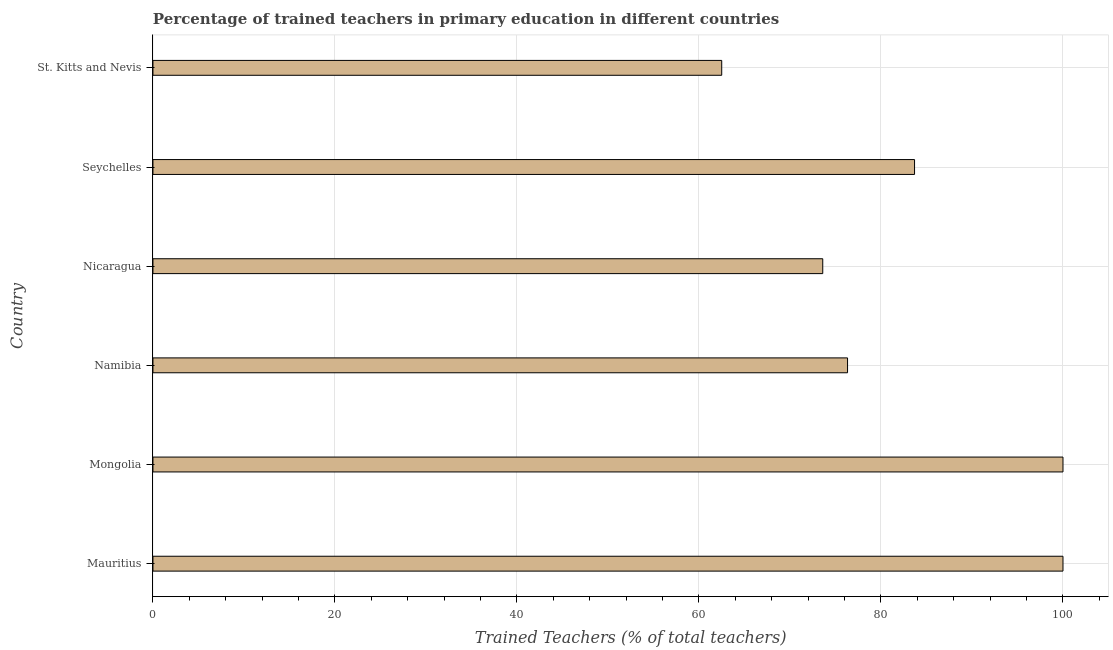Does the graph contain grids?
Your answer should be very brief. Yes. What is the title of the graph?
Make the answer very short. Percentage of trained teachers in primary education in different countries. What is the label or title of the X-axis?
Keep it short and to the point. Trained Teachers (% of total teachers). What is the label or title of the Y-axis?
Ensure brevity in your answer.  Country. What is the percentage of trained teachers in St. Kitts and Nevis?
Provide a short and direct response. 62.5. Across all countries, what is the maximum percentage of trained teachers?
Provide a succinct answer. 100. Across all countries, what is the minimum percentage of trained teachers?
Make the answer very short. 62.5. In which country was the percentage of trained teachers maximum?
Offer a very short reply. Mauritius. In which country was the percentage of trained teachers minimum?
Keep it short and to the point. St. Kitts and Nevis. What is the sum of the percentage of trained teachers?
Provide a short and direct response. 496.12. What is the difference between the percentage of trained teachers in Mongolia and Nicaragua?
Keep it short and to the point. 26.4. What is the average percentage of trained teachers per country?
Make the answer very short. 82.69. What is the median percentage of trained teachers?
Give a very brief answer. 80.01. What is the ratio of the percentage of trained teachers in Mongolia to that in Seychelles?
Give a very brief answer. 1.2. What is the difference between the highest and the second highest percentage of trained teachers?
Your answer should be very brief. 0. Is the sum of the percentage of trained teachers in Seychelles and St. Kitts and Nevis greater than the maximum percentage of trained teachers across all countries?
Your answer should be very brief. Yes. What is the difference between the highest and the lowest percentage of trained teachers?
Your response must be concise. 37.5. What is the difference between two consecutive major ticks on the X-axis?
Make the answer very short. 20. Are the values on the major ticks of X-axis written in scientific E-notation?
Your answer should be compact. No. What is the Trained Teachers (% of total teachers) in Mauritius?
Provide a succinct answer. 100. What is the Trained Teachers (% of total teachers) in Mongolia?
Your answer should be compact. 100. What is the Trained Teachers (% of total teachers) of Namibia?
Offer a very short reply. 76.33. What is the Trained Teachers (% of total teachers) in Nicaragua?
Your answer should be very brief. 73.6. What is the Trained Teachers (% of total teachers) in Seychelles?
Your answer should be very brief. 83.69. What is the Trained Teachers (% of total teachers) in St. Kitts and Nevis?
Provide a short and direct response. 62.5. What is the difference between the Trained Teachers (% of total teachers) in Mauritius and Namibia?
Your answer should be very brief. 23.67. What is the difference between the Trained Teachers (% of total teachers) in Mauritius and Nicaragua?
Ensure brevity in your answer.  26.4. What is the difference between the Trained Teachers (% of total teachers) in Mauritius and Seychelles?
Keep it short and to the point. 16.31. What is the difference between the Trained Teachers (% of total teachers) in Mauritius and St. Kitts and Nevis?
Keep it short and to the point. 37.5. What is the difference between the Trained Teachers (% of total teachers) in Mongolia and Namibia?
Give a very brief answer. 23.67. What is the difference between the Trained Teachers (% of total teachers) in Mongolia and Nicaragua?
Give a very brief answer. 26.4. What is the difference between the Trained Teachers (% of total teachers) in Mongolia and Seychelles?
Your answer should be very brief. 16.31. What is the difference between the Trained Teachers (% of total teachers) in Mongolia and St. Kitts and Nevis?
Provide a short and direct response. 37.5. What is the difference between the Trained Teachers (% of total teachers) in Namibia and Nicaragua?
Provide a short and direct response. 2.73. What is the difference between the Trained Teachers (% of total teachers) in Namibia and Seychelles?
Ensure brevity in your answer.  -7.36. What is the difference between the Trained Teachers (% of total teachers) in Namibia and St. Kitts and Nevis?
Offer a very short reply. 13.83. What is the difference between the Trained Teachers (% of total teachers) in Nicaragua and Seychelles?
Give a very brief answer. -10.09. What is the difference between the Trained Teachers (% of total teachers) in Nicaragua and St. Kitts and Nevis?
Make the answer very short. 11.1. What is the difference between the Trained Teachers (% of total teachers) in Seychelles and St. Kitts and Nevis?
Offer a terse response. 21.19. What is the ratio of the Trained Teachers (% of total teachers) in Mauritius to that in Namibia?
Your response must be concise. 1.31. What is the ratio of the Trained Teachers (% of total teachers) in Mauritius to that in Nicaragua?
Your answer should be very brief. 1.36. What is the ratio of the Trained Teachers (% of total teachers) in Mauritius to that in Seychelles?
Provide a succinct answer. 1.2. What is the ratio of the Trained Teachers (% of total teachers) in Mongolia to that in Namibia?
Your response must be concise. 1.31. What is the ratio of the Trained Teachers (% of total teachers) in Mongolia to that in Nicaragua?
Make the answer very short. 1.36. What is the ratio of the Trained Teachers (% of total teachers) in Mongolia to that in Seychelles?
Your answer should be very brief. 1.2. What is the ratio of the Trained Teachers (% of total teachers) in Mongolia to that in St. Kitts and Nevis?
Your answer should be compact. 1.6. What is the ratio of the Trained Teachers (% of total teachers) in Namibia to that in Nicaragua?
Give a very brief answer. 1.04. What is the ratio of the Trained Teachers (% of total teachers) in Namibia to that in Seychelles?
Offer a terse response. 0.91. What is the ratio of the Trained Teachers (% of total teachers) in Namibia to that in St. Kitts and Nevis?
Provide a short and direct response. 1.22. What is the ratio of the Trained Teachers (% of total teachers) in Nicaragua to that in Seychelles?
Your answer should be very brief. 0.88. What is the ratio of the Trained Teachers (% of total teachers) in Nicaragua to that in St. Kitts and Nevis?
Ensure brevity in your answer.  1.18. What is the ratio of the Trained Teachers (% of total teachers) in Seychelles to that in St. Kitts and Nevis?
Keep it short and to the point. 1.34. 